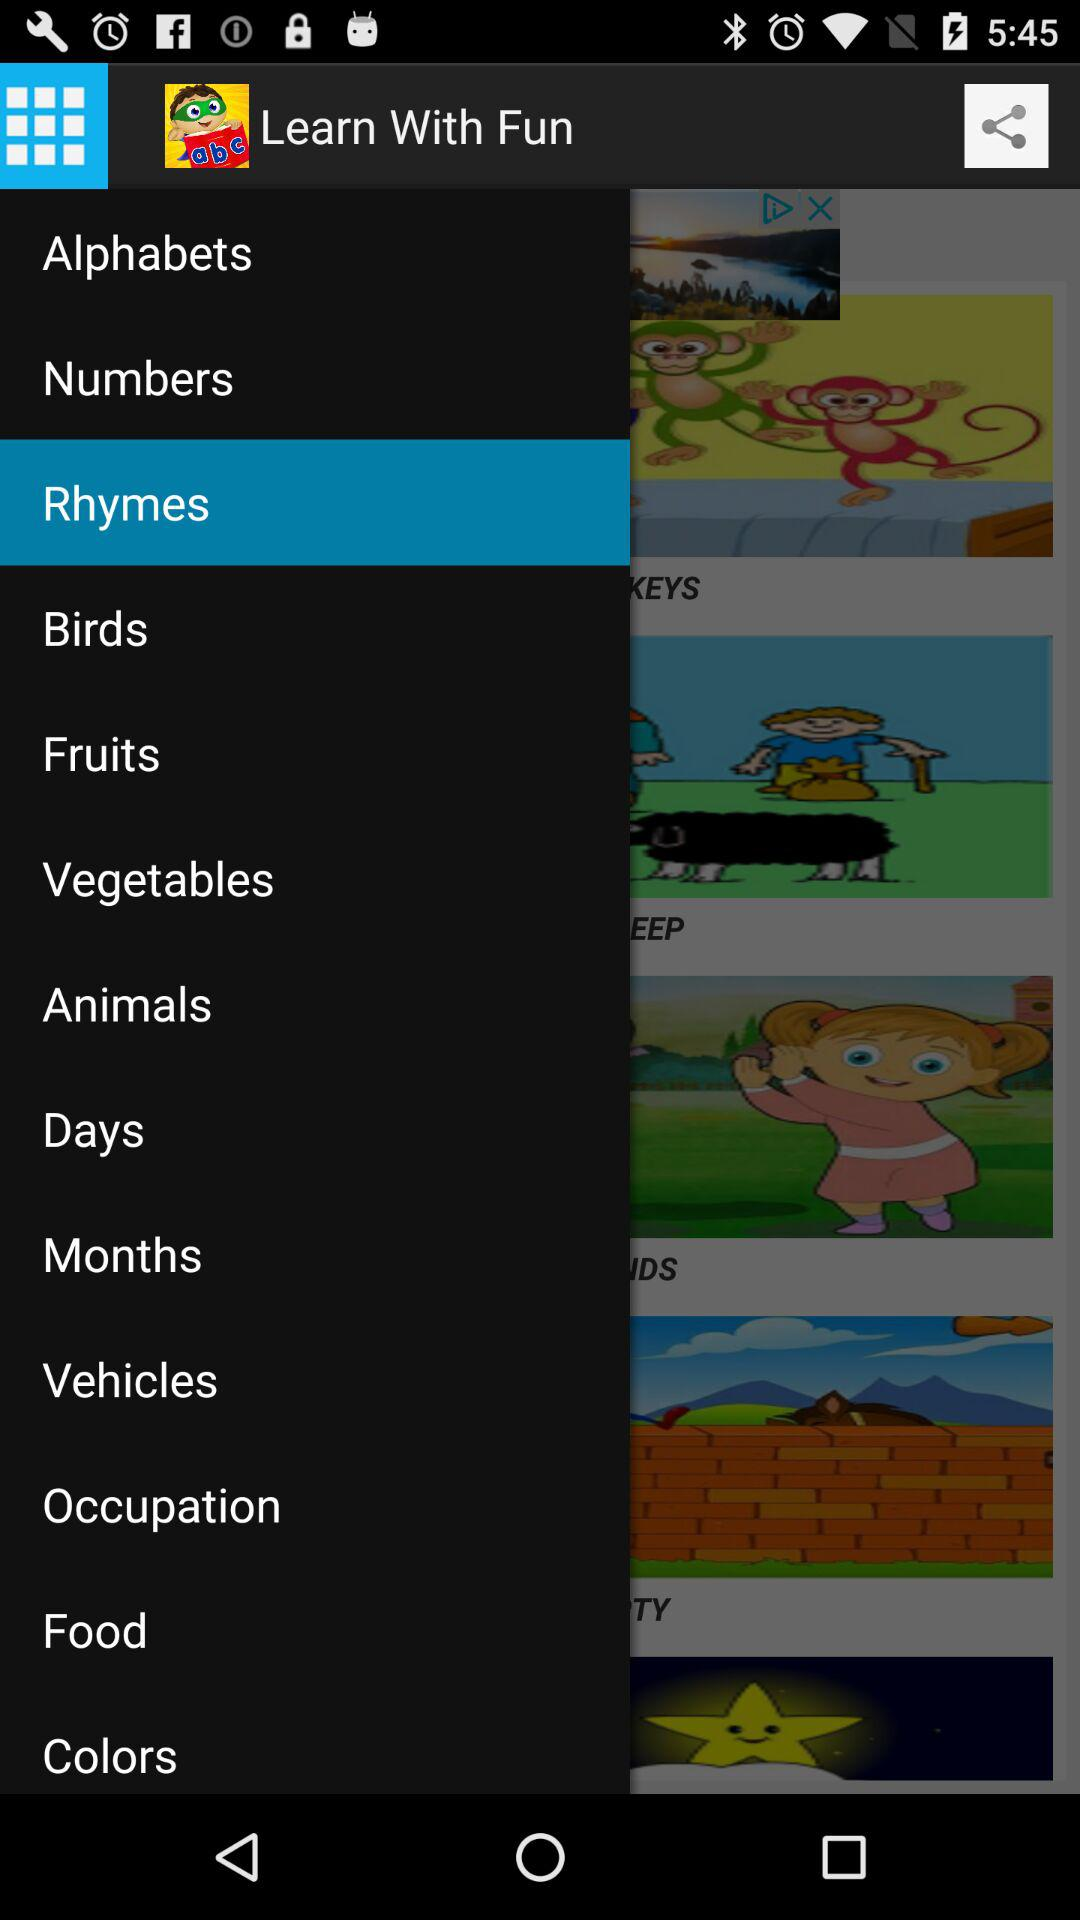Which item is selected? The selected item is "Rhymes". 